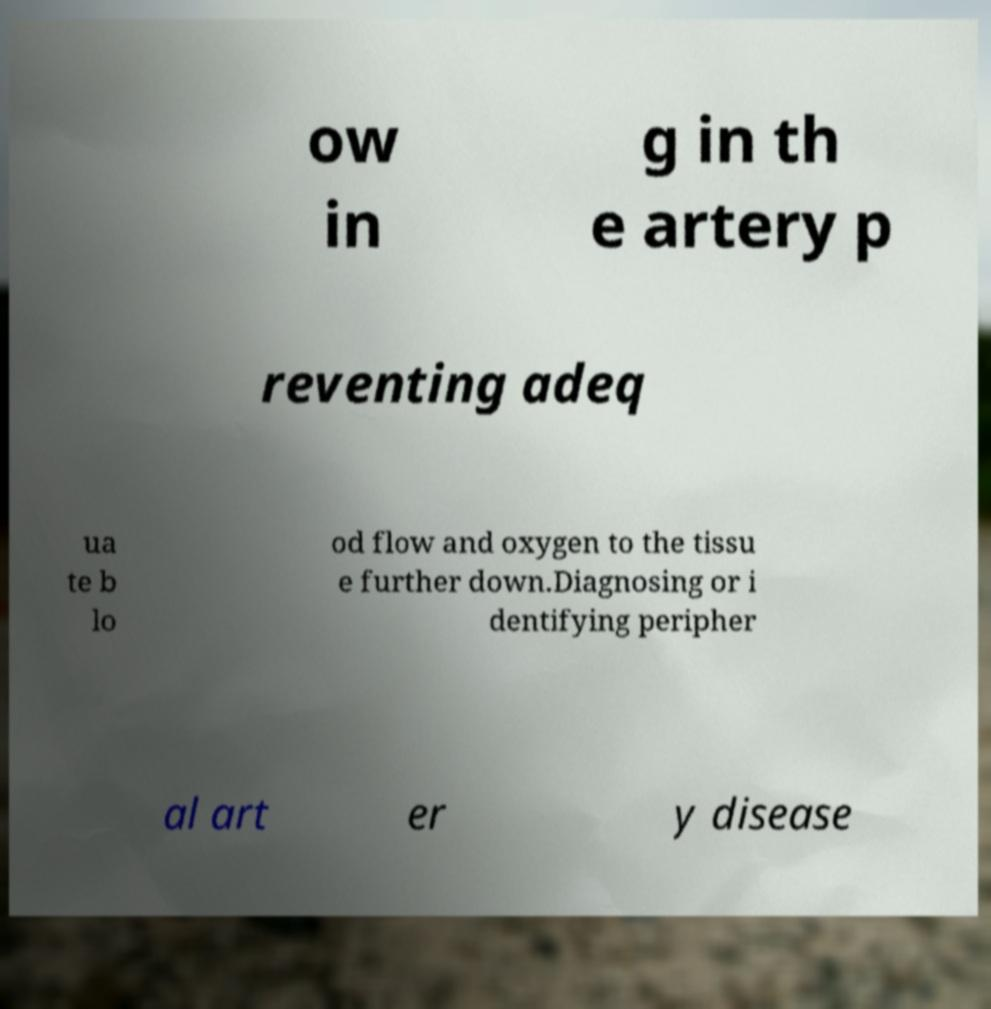Could you extract and type out the text from this image? ow in g in th e artery p reventing adeq ua te b lo od flow and oxygen to the tissu e further down.Diagnosing or i dentifying peripher al art er y disease 